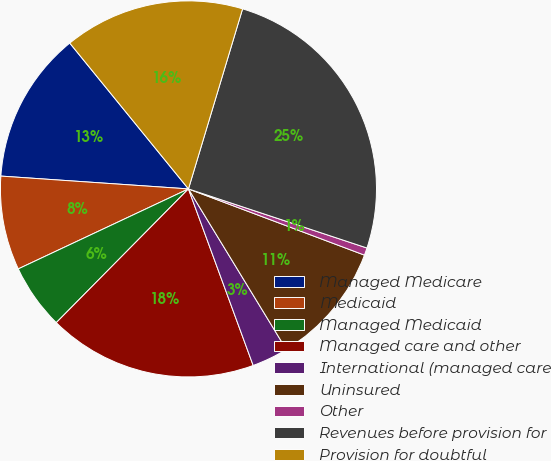Convert chart. <chart><loc_0><loc_0><loc_500><loc_500><pie_chart><fcel>Managed Medicare<fcel>Medicaid<fcel>Managed Medicaid<fcel>Managed care and other<fcel>International (managed care<fcel>Uninsured<fcel>Other<fcel>Revenues before provision for<fcel>Provision for doubtful<nl><fcel>13.04%<fcel>8.08%<fcel>5.6%<fcel>18.0%<fcel>3.12%<fcel>10.56%<fcel>0.64%<fcel>25.44%<fcel>15.52%<nl></chart> 